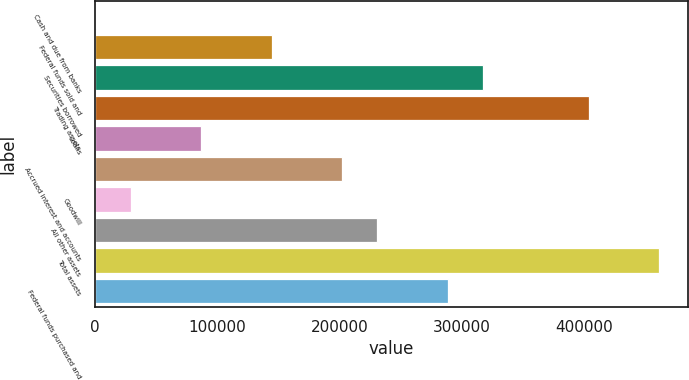Convert chart. <chart><loc_0><loc_0><loc_500><loc_500><bar_chart><fcel>Cash and due from banks<fcel>Federal funds sold and<fcel>Securities borrowed<fcel>Trading assets<fcel>Loans<fcel>Accrued interest and accounts<fcel>Goodwill<fcel>All other assets<fcel>Total assets<fcel>Federal funds purchased and<nl><fcel>534<fcel>144651<fcel>317591<fcel>404062<fcel>87004.2<fcel>202298<fcel>29357.4<fcel>231121<fcel>461708<fcel>288768<nl></chart> 